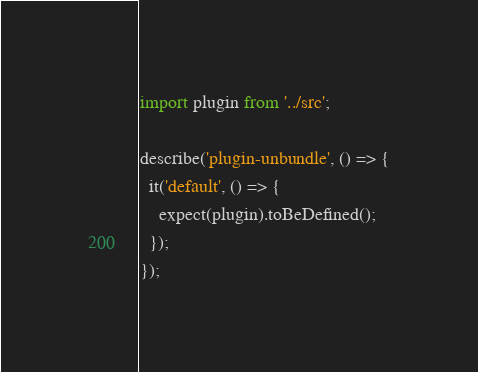Convert code to text. <code><loc_0><loc_0><loc_500><loc_500><_TypeScript_>import plugin from '../src';

describe('plugin-unbundle', () => {
  it('default', () => {
    expect(plugin).toBeDefined();
  });
});
</code> 